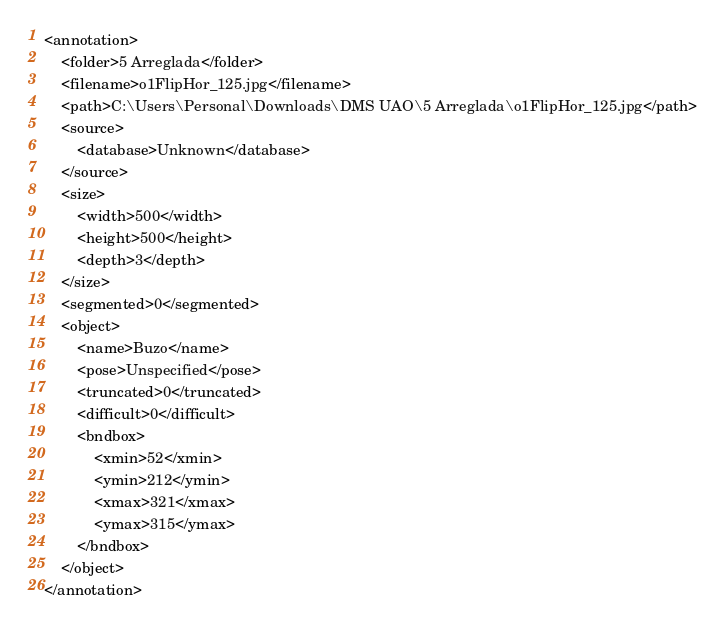<code> <loc_0><loc_0><loc_500><loc_500><_XML_><annotation>
	<folder>5 Arreglada</folder>
	<filename>o1FlipHor_125.jpg</filename>
	<path>C:\Users\Personal\Downloads\DMS UAO\5 Arreglada\o1FlipHor_125.jpg</path>
	<source>
		<database>Unknown</database>
	</source>
	<size>
		<width>500</width>
		<height>500</height>
		<depth>3</depth>
	</size>
	<segmented>0</segmented>
	<object>
		<name>Buzo</name>
		<pose>Unspecified</pose>
		<truncated>0</truncated>
		<difficult>0</difficult>
		<bndbox>
			<xmin>52</xmin>
			<ymin>212</ymin>
			<xmax>321</xmax>
			<ymax>315</ymax>
		</bndbox>
	</object>
</annotation>
</code> 